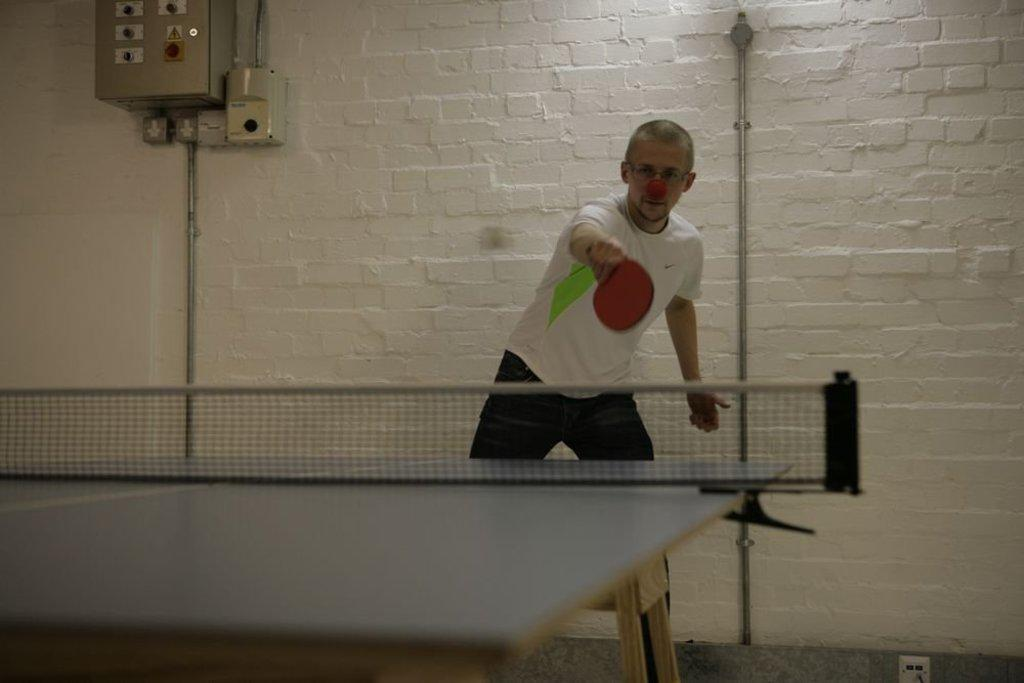What is the man in the image doing? The man is playing badminton. What can be seen behind the man in the image? There is a white color wall behind the man. What emotion is the man expressing while playing badminton in the image? The image does not show any specific emotion being expressed by the man while playing badminton. 